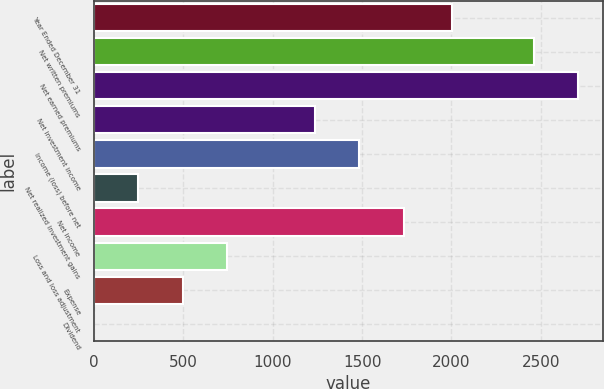Convert chart. <chart><loc_0><loc_0><loc_500><loc_500><bar_chart><fcel>Year Ended December 31<fcel>Net written premiums<fcel>Net earned premiums<fcel>Net investment income<fcel>Income (loss) before net<fcel>Net realized investment gains<fcel>Net income<fcel>Loss and loss adjustment<fcel>Expense<fcel>Dividend<nl><fcel>2005<fcel>2463<fcel>2710.48<fcel>1237.6<fcel>1485.08<fcel>247.68<fcel>1732.56<fcel>742.64<fcel>495.16<fcel>0.2<nl></chart> 